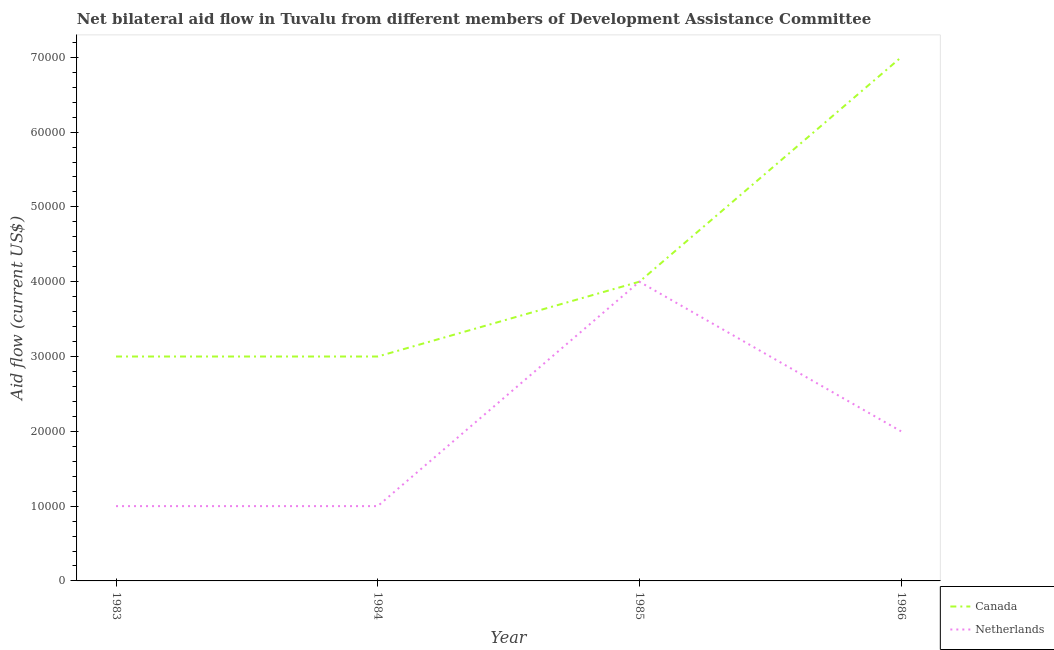How many different coloured lines are there?
Make the answer very short. 2. What is the amount of aid given by canada in 1986?
Your answer should be very brief. 7.00e+04. Across all years, what is the maximum amount of aid given by netherlands?
Ensure brevity in your answer.  4.00e+04. Across all years, what is the minimum amount of aid given by canada?
Keep it short and to the point. 3.00e+04. In which year was the amount of aid given by netherlands maximum?
Make the answer very short. 1985. In which year was the amount of aid given by canada minimum?
Provide a short and direct response. 1983. What is the total amount of aid given by netherlands in the graph?
Give a very brief answer. 8.00e+04. What is the difference between the amount of aid given by canada in 1983 and that in 1986?
Offer a very short reply. -4.00e+04. What is the difference between the amount of aid given by canada in 1983 and the amount of aid given by netherlands in 1984?
Offer a very short reply. 2.00e+04. In the year 1986, what is the difference between the amount of aid given by canada and amount of aid given by netherlands?
Your answer should be compact. 5.00e+04. In how many years, is the amount of aid given by canada greater than 36000 US$?
Give a very brief answer. 2. What is the ratio of the amount of aid given by netherlands in 1983 to that in 1984?
Your answer should be very brief. 1. Is the difference between the amount of aid given by canada in 1984 and 1985 greater than the difference between the amount of aid given by netherlands in 1984 and 1985?
Make the answer very short. Yes. What is the difference between the highest and the lowest amount of aid given by netherlands?
Provide a short and direct response. 3.00e+04. Does the amount of aid given by netherlands monotonically increase over the years?
Offer a very short reply. No. Is the amount of aid given by netherlands strictly greater than the amount of aid given by canada over the years?
Offer a terse response. No. Is the amount of aid given by canada strictly less than the amount of aid given by netherlands over the years?
Provide a succinct answer. No. How many lines are there?
Give a very brief answer. 2. How many years are there in the graph?
Your answer should be very brief. 4. Does the graph contain grids?
Provide a succinct answer. No. Where does the legend appear in the graph?
Your answer should be compact. Bottom right. How are the legend labels stacked?
Provide a succinct answer. Vertical. What is the title of the graph?
Provide a short and direct response. Net bilateral aid flow in Tuvalu from different members of Development Assistance Committee. Does "Residents" appear as one of the legend labels in the graph?
Ensure brevity in your answer.  No. What is the label or title of the X-axis?
Your answer should be compact. Year. What is the label or title of the Y-axis?
Your answer should be compact. Aid flow (current US$). What is the Aid flow (current US$) in Canada in 1983?
Provide a short and direct response. 3.00e+04. What is the Aid flow (current US$) of Canada in 1984?
Offer a terse response. 3.00e+04. What is the Aid flow (current US$) in Netherlands in 1986?
Offer a terse response. 2.00e+04. Across all years, what is the maximum Aid flow (current US$) of Netherlands?
Provide a succinct answer. 4.00e+04. Across all years, what is the minimum Aid flow (current US$) in Canada?
Your response must be concise. 3.00e+04. Across all years, what is the minimum Aid flow (current US$) of Netherlands?
Give a very brief answer. 10000. What is the total Aid flow (current US$) of Canada in the graph?
Offer a very short reply. 1.70e+05. What is the total Aid flow (current US$) in Netherlands in the graph?
Make the answer very short. 8.00e+04. What is the difference between the Aid flow (current US$) in Canada in 1983 and that in 1986?
Offer a terse response. -4.00e+04. What is the difference between the Aid flow (current US$) of Canada in 1984 and that in 1985?
Provide a short and direct response. -10000. What is the difference between the Aid flow (current US$) in Canada in 1985 and that in 1986?
Give a very brief answer. -3.00e+04. What is the difference between the Aid flow (current US$) of Canada in 1983 and the Aid flow (current US$) of Netherlands in 1984?
Your answer should be compact. 2.00e+04. What is the difference between the Aid flow (current US$) in Canada in 1983 and the Aid flow (current US$) in Netherlands in 1985?
Provide a short and direct response. -10000. What is the difference between the Aid flow (current US$) in Canada in 1983 and the Aid flow (current US$) in Netherlands in 1986?
Give a very brief answer. 10000. What is the difference between the Aid flow (current US$) in Canada in 1984 and the Aid flow (current US$) in Netherlands in 1986?
Ensure brevity in your answer.  10000. What is the average Aid flow (current US$) in Canada per year?
Your answer should be very brief. 4.25e+04. In the year 1983, what is the difference between the Aid flow (current US$) in Canada and Aid flow (current US$) in Netherlands?
Provide a succinct answer. 2.00e+04. In the year 1984, what is the difference between the Aid flow (current US$) of Canada and Aid flow (current US$) of Netherlands?
Offer a terse response. 2.00e+04. What is the ratio of the Aid flow (current US$) of Canada in 1983 to that in 1984?
Offer a very short reply. 1. What is the ratio of the Aid flow (current US$) in Canada in 1983 to that in 1986?
Offer a terse response. 0.43. What is the ratio of the Aid flow (current US$) in Netherlands in 1983 to that in 1986?
Make the answer very short. 0.5. What is the ratio of the Aid flow (current US$) in Canada in 1984 to that in 1985?
Your response must be concise. 0.75. What is the ratio of the Aid flow (current US$) of Canada in 1984 to that in 1986?
Offer a very short reply. 0.43. What is the ratio of the Aid flow (current US$) in Netherlands in 1985 to that in 1986?
Provide a short and direct response. 2. What is the difference between the highest and the second highest Aid flow (current US$) of Canada?
Make the answer very short. 3.00e+04. What is the difference between the highest and the lowest Aid flow (current US$) of Canada?
Offer a terse response. 4.00e+04. What is the difference between the highest and the lowest Aid flow (current US$) of Netherlands?
Provide a succinct answer. 3.00e+04. 